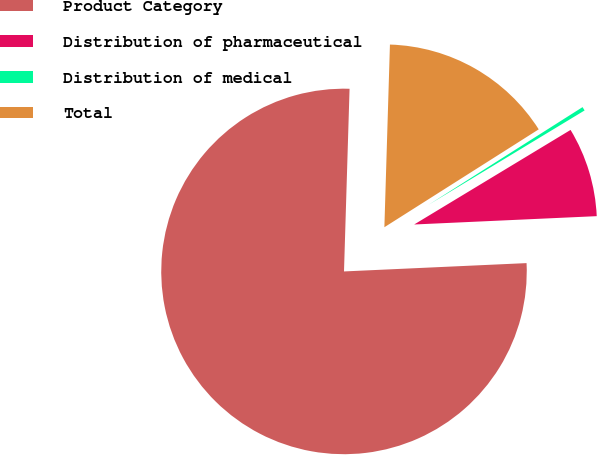Convert chart. <chart><loc_0><loc_0><loc_500><loc_500><pie_chart><fcel>Product Category<fcel>Distribution of pharmaceutical<fcel>Distribution of medical<fcel>Total<nl><fcel>76.21%<fcel>7.93%<fcel>0.34%<fcel>15.52%<nl></chart> 